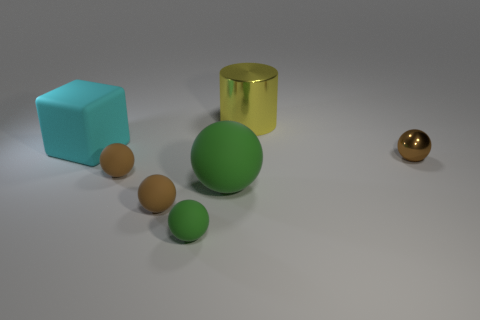There is a block that is in front of the yellow metal object; what is it made of?
Make the answer very short. Rubber. How many small objects are red metallic objects or metal cylinders?
Ensure brevity in your answer.  0. Are there any big cubes made of the same material as the cyan thing?
Give a very brief answer. No. There is a brown object right of the yellow metallic object; is it the same size as the small green matte ball?
Offer a terse response. Yes. Are there any cylinders right of the cylinder to the right of the matte object that is to the right of the small green rubber thing?
Ensure brevity in your answer.  No. What number of matte things are big green things or big objects?
Keep it short and to the point. 2. How many other things are there of the same shape as the big metal object?
Your response must be concise. 0. Are there more large green rubber things than large green rubber blocks?
Offer a very short reply. Yes. How big is the brown rubber ball that is to the left of the brown object that is in front of the big matte object on the right side of the large cyan cube?
Your answer should be compact. Small. There is a brown metallic sphere in front of the large block; what size is it?
Your answer should be compact. Small. 